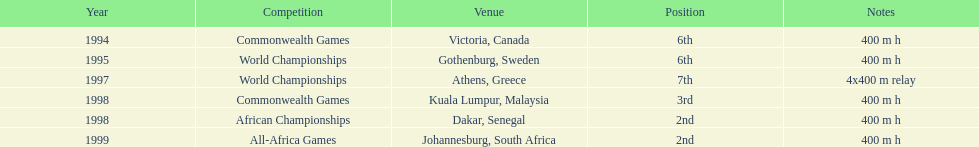What is the final contest on the graph? All-Africa Games. 